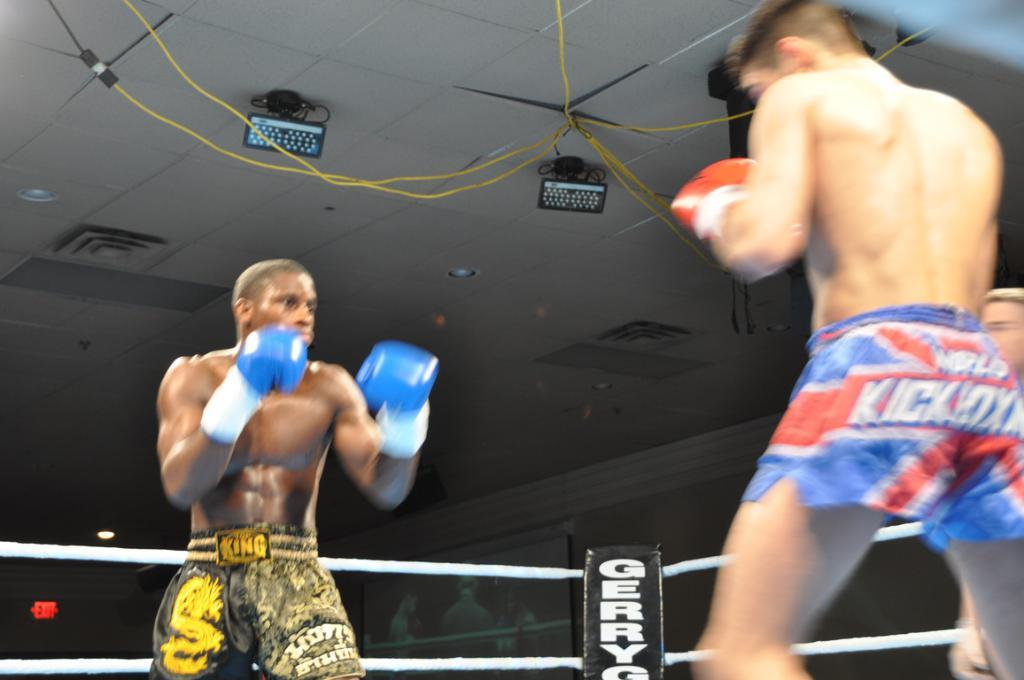<image>
Share a concise interpretation of the image provided. Boxing match with the word GerryG visible in the ring 